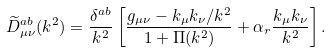<formula> <loc_0><loc_0><loc_500><loc_500>\widetilde { D } _ { \mu \nu } ^ { a b } ( k ^ { 2 } ) = \frac { \delta ^ { a b } } { k ^ { 2 } } \left [ \frac { g _ { \mu \nu } - k _ { \mu } k _ { \nu } / k ^ { 2 } } { 1 + \Pi ( k ^ { 2 } ) } + \alpha _ { r } \frac { k _ { \mu } k _ { \nu } } { k ^ { 2 } } \right ] .</formula> 